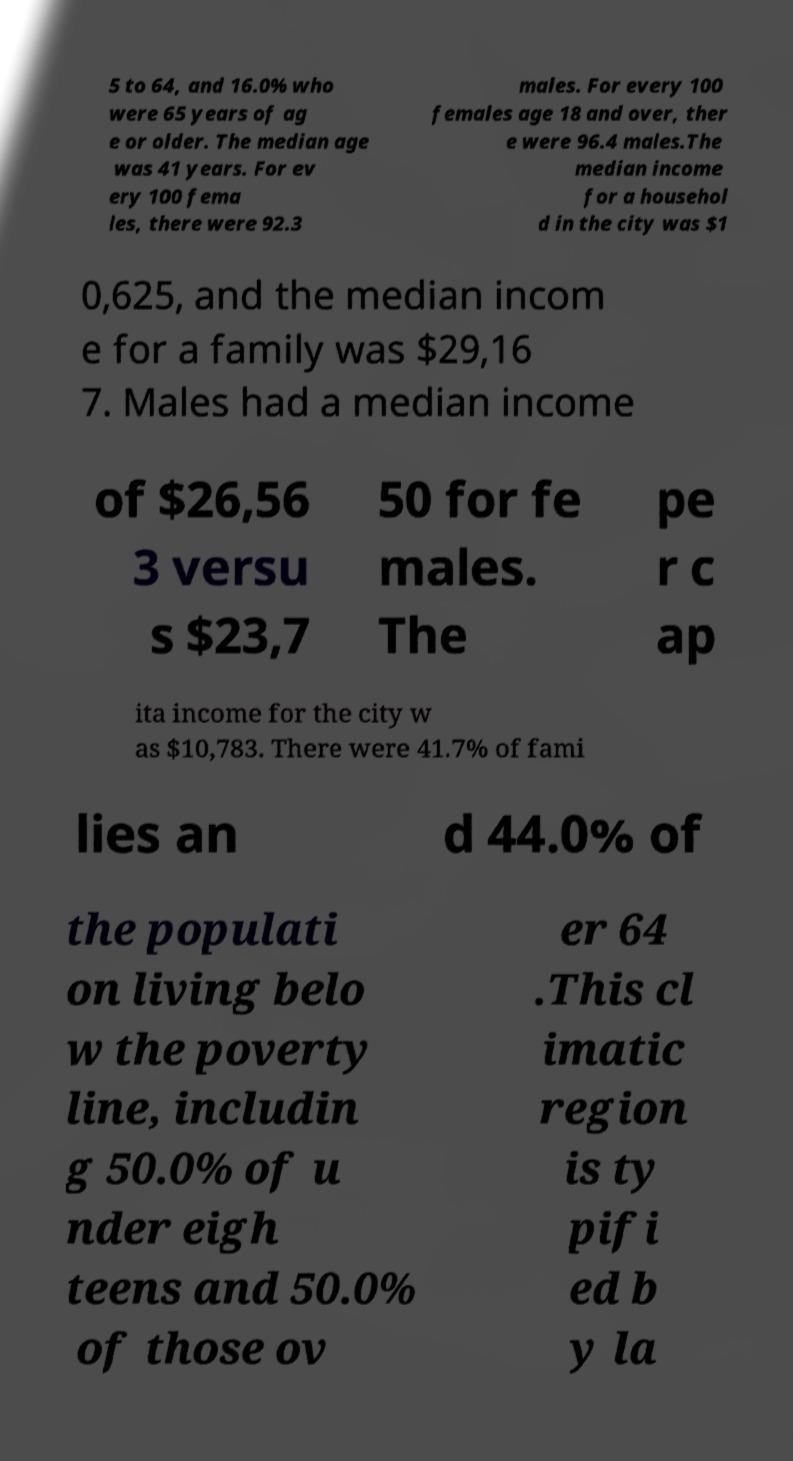Can you read and provide the text displayed in the image?This photo seems to have some interesting text. Can you extract and type it out for me? 5 to 64, and 16.0% who were 65 years of ag e or older. The median age was 41 years. For ev ery 100 fema les, there were 92.3 males. For every 100 females age 18 and over, ther e were 96.4 males.The median income for a househol d in the city was $1 0,625, and the median incom e for a family was $29,16 7. Males had a median income of $26,56 3 versu s $23,7 50 for fe males. The pe r c ap ita income for the city w as $10,783. There were 41.7% of fami lies an d 44.0% of the populati on living belo w the poverty line, includin g 50.0% of u nder eigh teens and 50.0% of those ov er 64 .This cl imatic region is ty pifi ed b y la 